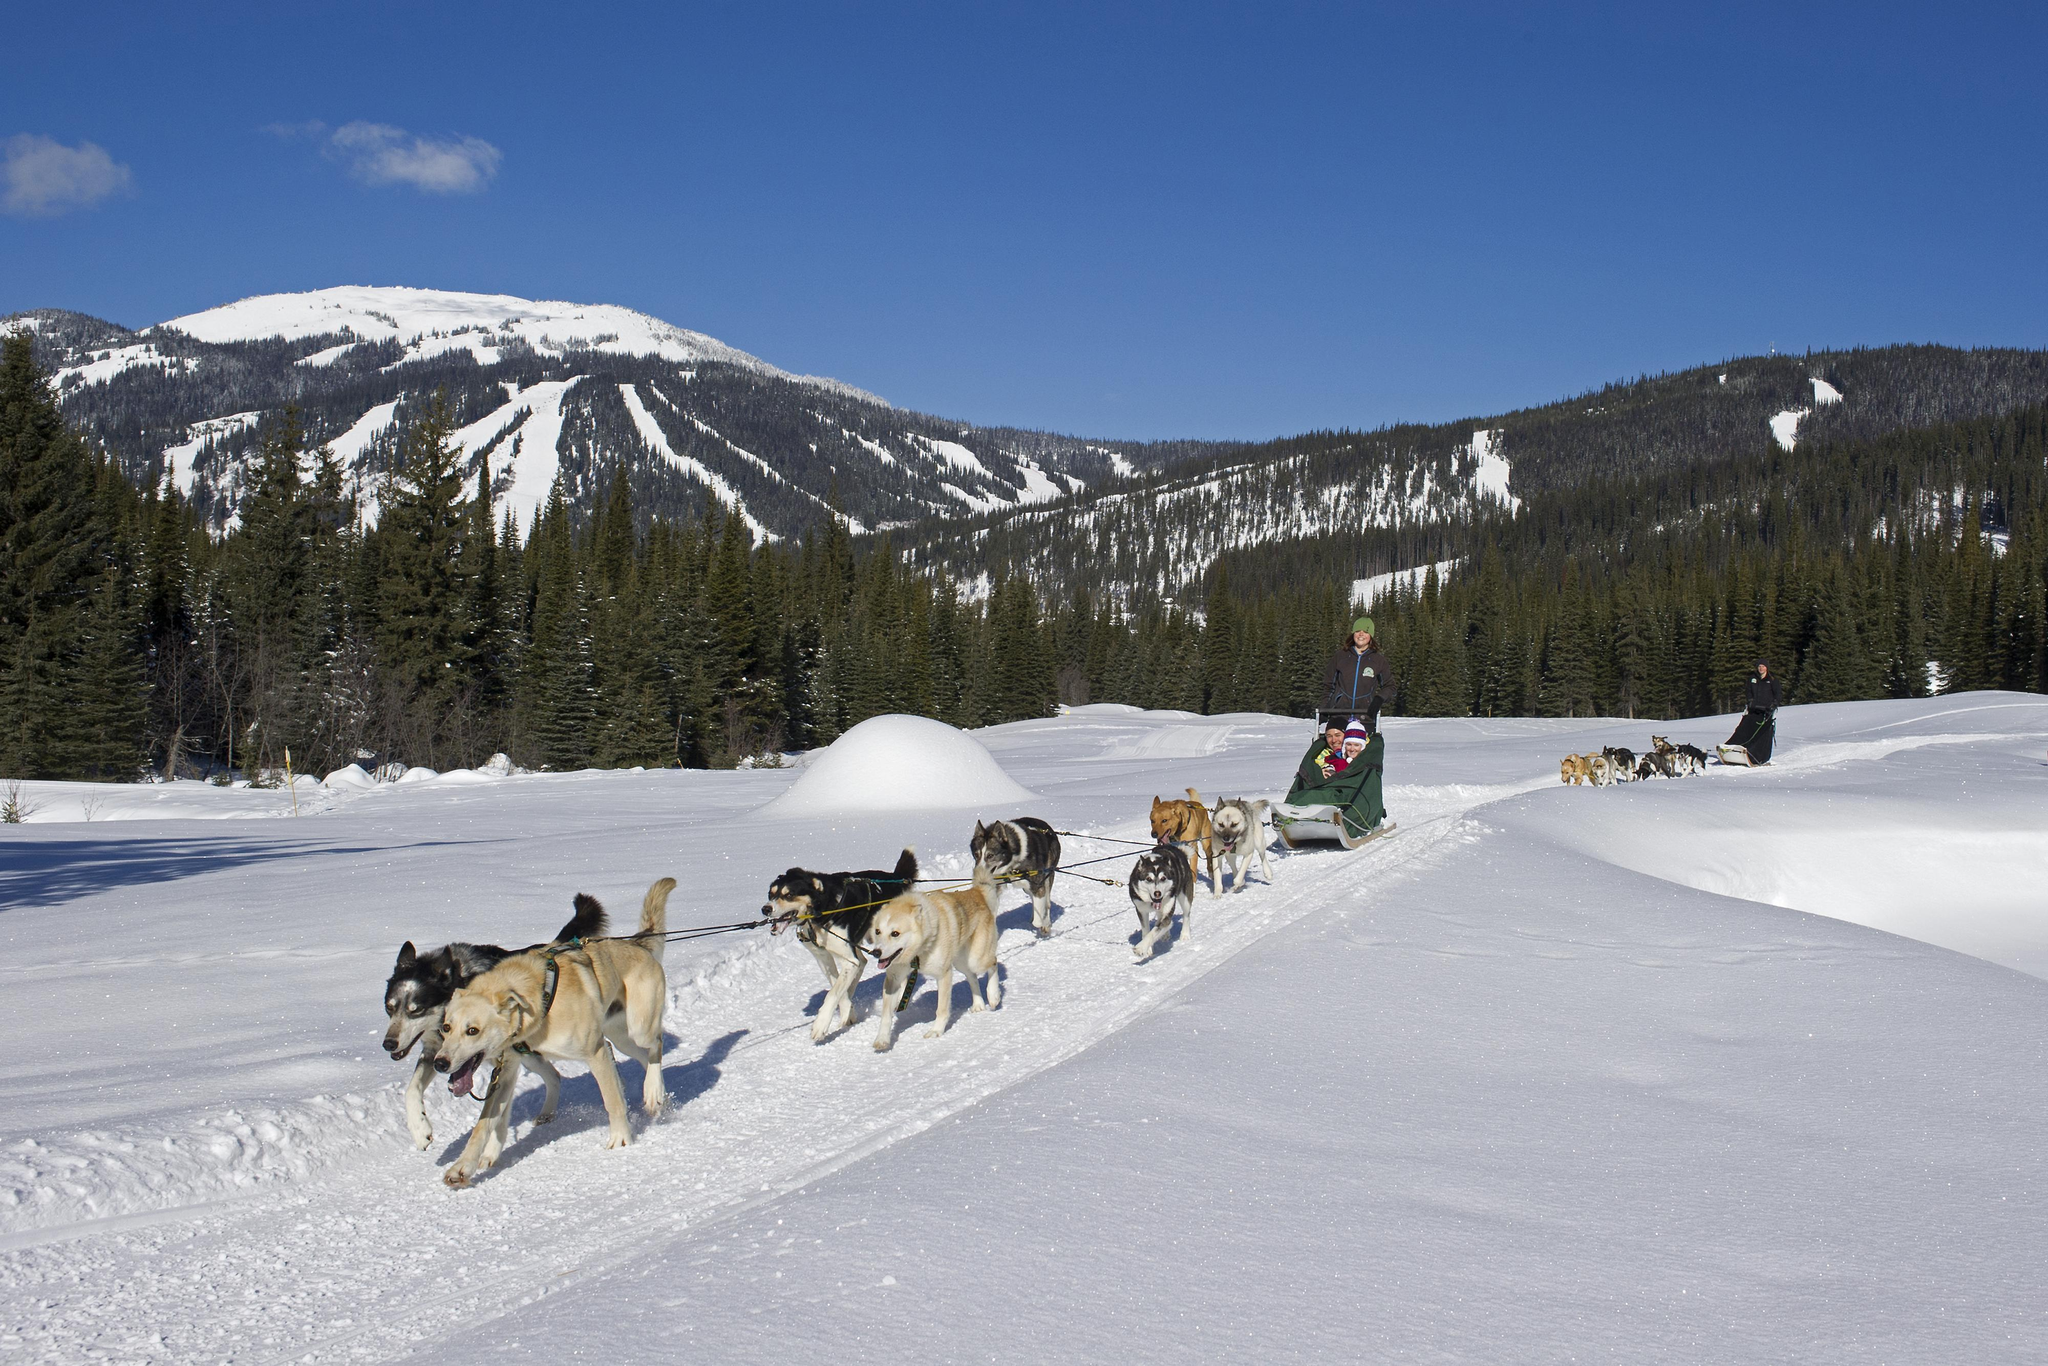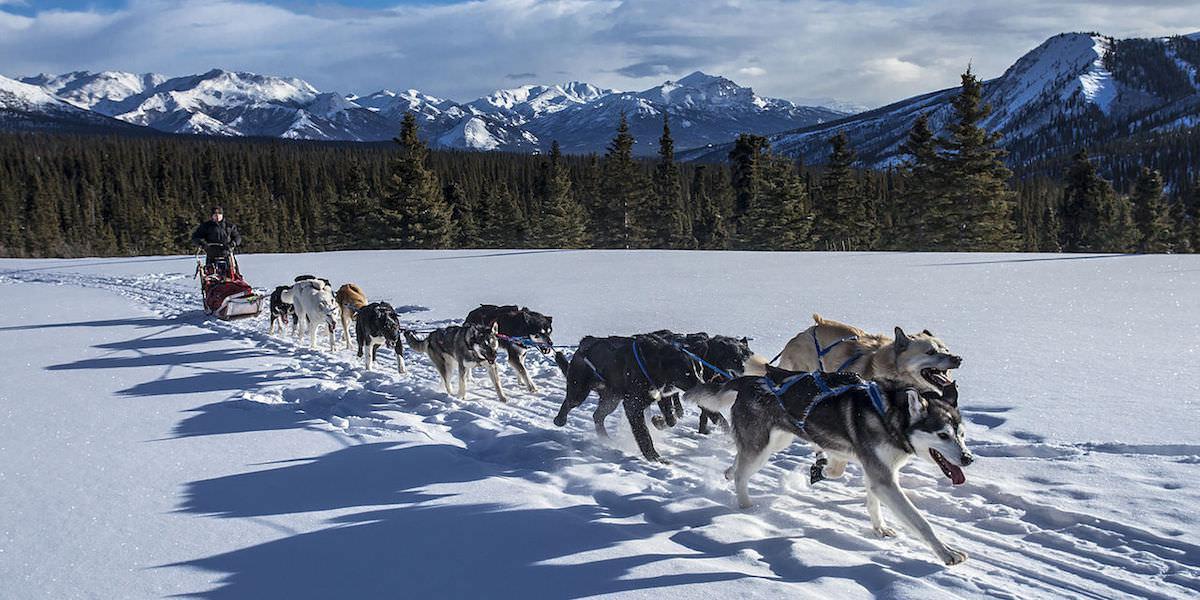The first image is the image on the left, the second image is the image on the right. For the images displayed, is the sentence "Mountains are visible behind the sled dogs" factually correct? Answer yes or no. Yes. The first image is the image on the left, the second image is the image on the right. Evaluate the accuracy of this statement regarding the images: "Right image shows sled dogs moving rightward, with a mountain backdrop.". Is it true? Answer yes or no. Yes. 